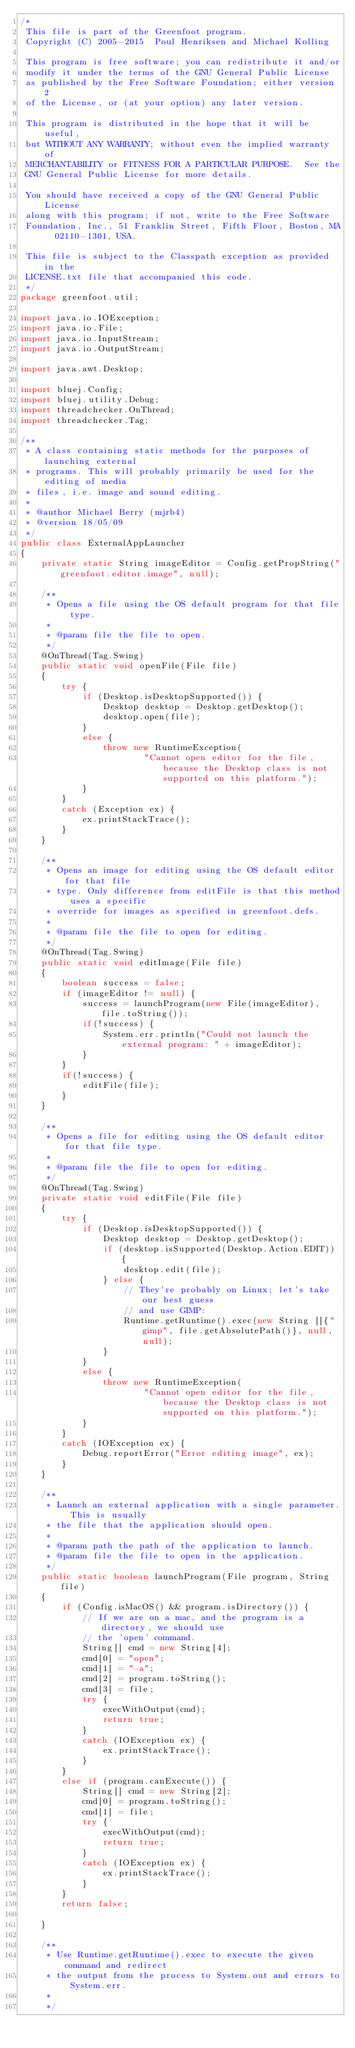Convert code to text. <code><loc_0><loc_0><loc_500><loc_500><_Java_>/*
 This file is part of the Greenfoot program. 
 Copyright (C) 2005-2015  Poul Henriksen and Michael Kolling 
 
 This program is free software; you can redistribute it and/or 
 modify it under the terms of the GNU General Public License 
 as published by the Free Software Foundation; either version 2 
 of the License, or (at your option) any later version. 
 
 This program is distributed in the hope that it will be useful, 
 but WITHOUT ANY WARRANTY; without even the implied warranty of 
 MERCHANTABILITY or FITNESS FOR A PARTICULAR PURPOSE.  See the 
 GNU General Public License for more details. 
 
 You should have received a copy of the GNU General Public License 
 along with this program; if not, write to the Free Software 
 Foundation, Inc., 51 Franklin Street, Fifth Floor, Boston, MA  02110-1301, USA. 
 
 This file is subject to the Classpath exception as provided in the  
 LICENSE.txt file that accompanied this code.
 */
package greenfoot.util;

import java.io.IOException;
import java.io.File;
import java.io.InputStream;
import java.io.OutputStream;

import java.awt.Desktop;

import bluej.Config;
import bluej.utility.Debug;
import threadchecker.OnThread;
import threadchecker.Tag;

/**
 * A class containing static methods for the purposes of launching external
 * programs. This will probably primarily be used for the editing of media
 * files, i.e. image and sound editing.
 * 
 * @author Michael Berry (mjrb4)
 * @version 18/05/09
 */
public class ExternalAppLauncher
{
    private static String imageEditor = Config.getPropString("greenfoot.editor.image", null);

    /**
     * Opens a file using the OS default program for that file type.
     * 
     * @param file the file to open.
     */
    @OnThread(Tag.Swing)
    public static void openFile(File file)
    {
        try {
            if (Desktop.isDesktopSupported()) {
                Desktop desktop = Desktop.getDesktop();
                desktop.open(file);
            }
            else {
                throw new RuntimeException(
                        "Cannot open editor for the file, because the Desktop class is not supported on this platform.");
            }
        }
        catch (Exception ex) {
            ex.printStackTrace();
        }
    }

    /**
     * Opens an image for editing using the OS default editor for that file
     * type. Only difference from editFile is that this method uses a specific
     * override for images as specified in greenfoot.defs.
     * 
     * @param file the file to open for editing.
     */
    @OnThread(Tag.Swing)
    public static void editImage(File file)
    {
        boolean success = false;
        if (imageEditor != null) {
            success = launchProgram(new File(imageEditor), file.toString());
            if(!success) {
                System.err.println("Could not launch the external program: " + imageEditor);
            } 
        }
        if(!success) {
            editFile(file);
        }
    }

    /**
     * Opens a file for editing using the OS default editor for that file type.
     * 
     * @param file the file to open for editing.
     */
    @OnThread(Tag.Swing)
    private static void editFile(File file)
    {
        try {
            if (Desktop.isDesktopSupported()) {
                Desktop desktop = Desktop.getDesktop();
                if (desktop.isSupported(Desktop.Action.EDIT)) {
                    desktop.edit(file);
                } else {
                    // They're probably on Linux; let's take our best guess
                    // and use GIMP:
                    Runtime.getRuntime().exec(new String []{"gimp", file.getAbsolutePath()}, null, null);
                }
            }
            else {
                throw new RuntimeException(
                        "Cannot open editor for the file, because the Desktop class is not supported on this platform.");
            }
        }
        catch (IOException ex) {
            Debug.reportError("Error editing image", ex);
        }
    }

    /**
     * Launch an external application with a single parameter. This is usually
     * the file that the application should open.
     * 
     * @param path the path of the application to launch.
     * @param file the file to open in the application.
     */
    public static boolean launchProgram(File program, String file)
    {
        if (Config.isMacOS() && program.isDirectory()) {
            // If we are on a mac, and the program is a directory, we should use
            // the 'open' command.
            String[] cmd = new String[4];
            cmd[0] = "open";
            cmd[1] = "-a";
            cmd[2] = program.toString();
            cmd[3] = file;
            try {
                execWithOutput(cmd);
                return true;
            }
            catch (IOException ex) {
                ex.printStackTrace();
            }
        }
        else if (program.canExecute()) {
            String[] cmd = new String[2];
            cmd[0] = program.toString();
            cmd[1] = file;
            try {
                execWithOutput(cmd);
                return true;
            }
            catch (IOException ex) {
                ex.printStackTrace();
            }
        }
        return false;    
        
    }

    /**
     * Use Runtime.getRuntime().exec to execute the given command and redirect
     * the output from the process to System.out and errors to System.err.
     * 
     */</code> 